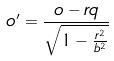<formula> <loc_0><loc_0><loc_500><loc_500>o ^ { \prime } = \frac { o - r q } { \sqrt { 1 - \frac { r ^ { 2 } } { b ^ { 2 } } } }</formula> 